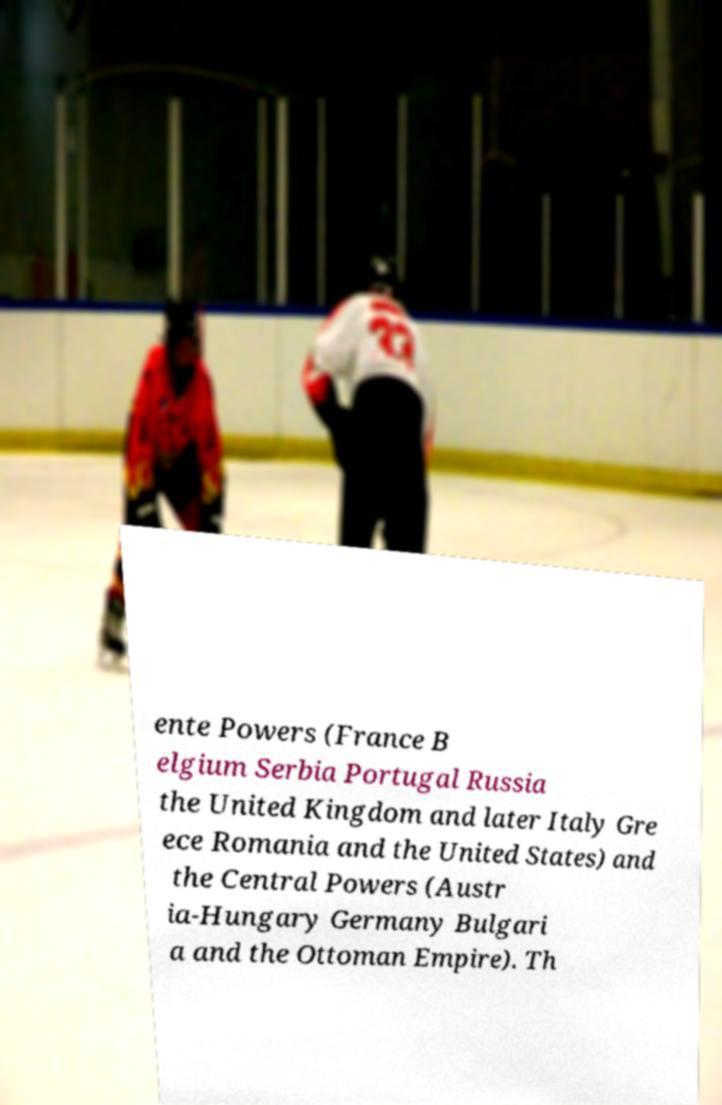For documentation purposes, I need the text within this image transcribed. Could you provide that? ente Powers (France B elgium Serbia Portugal Russia the United Kingdom and later Italy Gre ece Romania and the United States) and the Central Powers (Austr ia-Hungary Germany Bulgari a and the Ottoman Empire). Th 